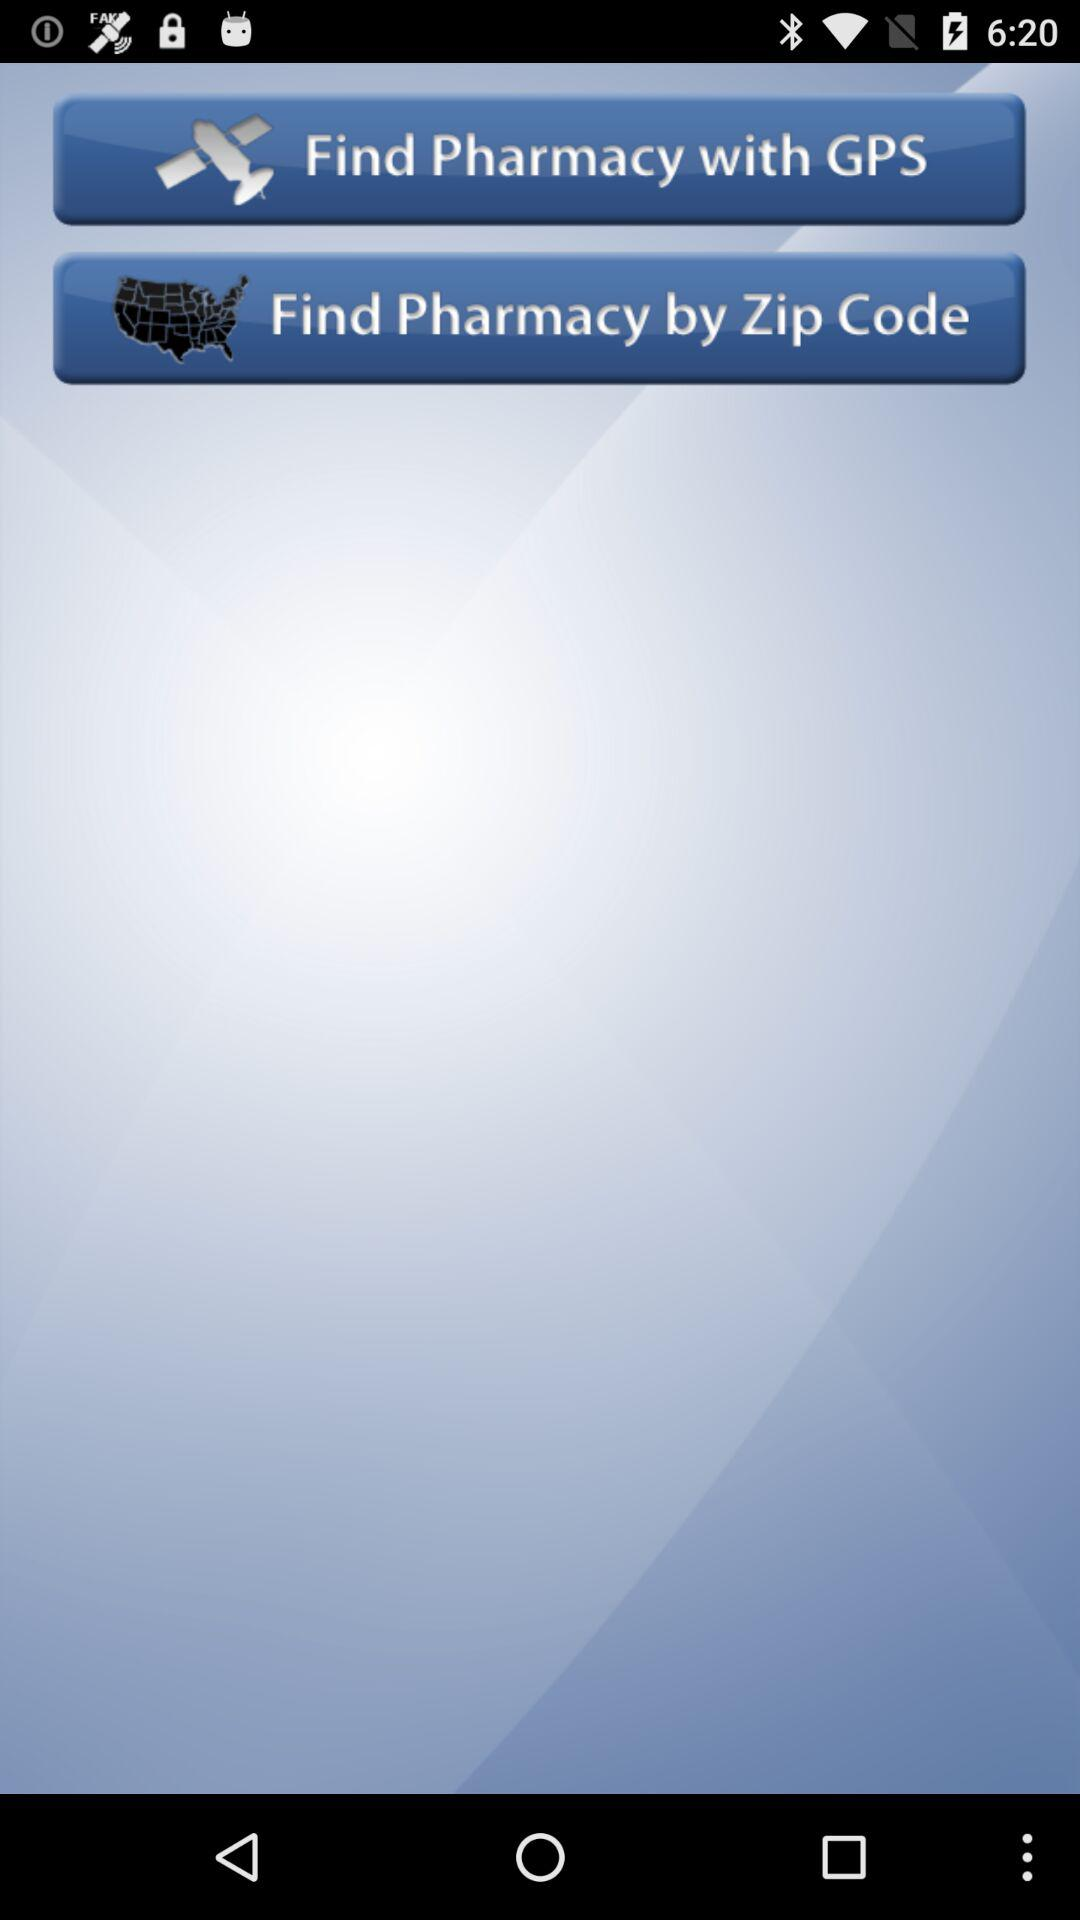How can we find a pharmacy? You can find a pharmacy through "GPS" and "Zip Code". 